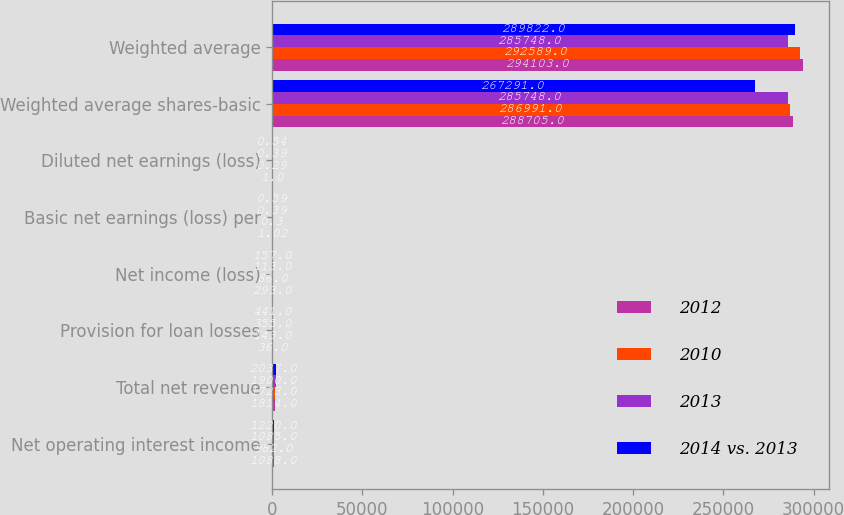Convert chart to OTSL. <chart><loc_0><loc_0><loc_500><loc_500><stacked_bar_chart><ecel><fcel>Net operating interest income<fcel>Total net revenue<fcel>Provision for loan losses<fcel>Net income (loss)<fcel>Basic net earnings (loss) per<fcel>Diluted net earnings (loss)<fcel>Weighted average shares-basic<fcel>Weighted average<nl><fcel>2012<fcel>1088<fcel>1814<fcel>36<fcel>293<fcel>1.02<fcel>1<fcel>288705<fcel>294103<nl><fcel>2010<fcel>982<fcel>1723<fcel>143<fcel>86<fcel>0.3<fcel>0.29<fcel>286991<fcel>292589<nl><fcel>2013<fcel>1085<fcel>1900<fcel>355<fcel>113<fcel>0.39<fcel>0.39<fcel>285748<fcel>285748<nl><fcel>2014 vs. 2013<fcel>1220<fcel>2037<fcel>441<fcel>157<fcel>0.59<fcel>0.54<fcel>267291<fcel>289822<nl></chart> 